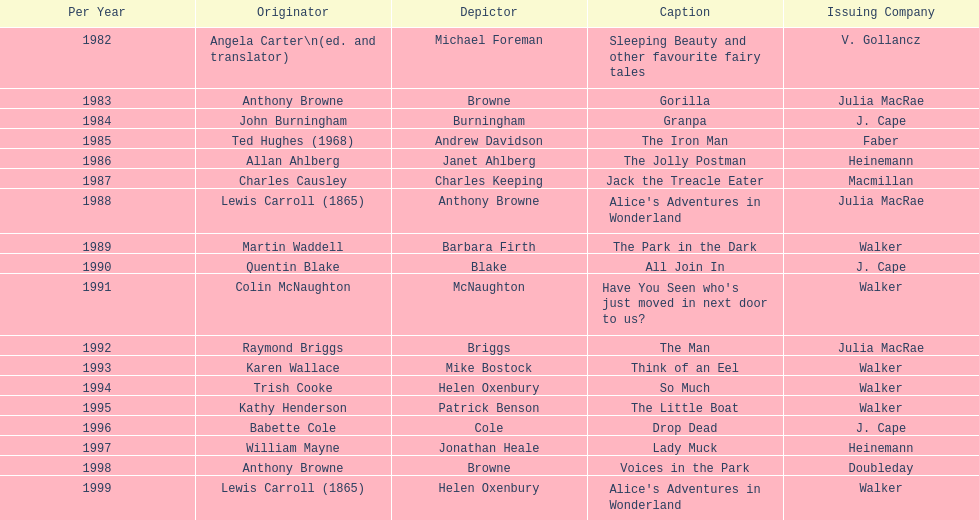What are the number of kurt maschler awards helen oxenbury has won? 2. 